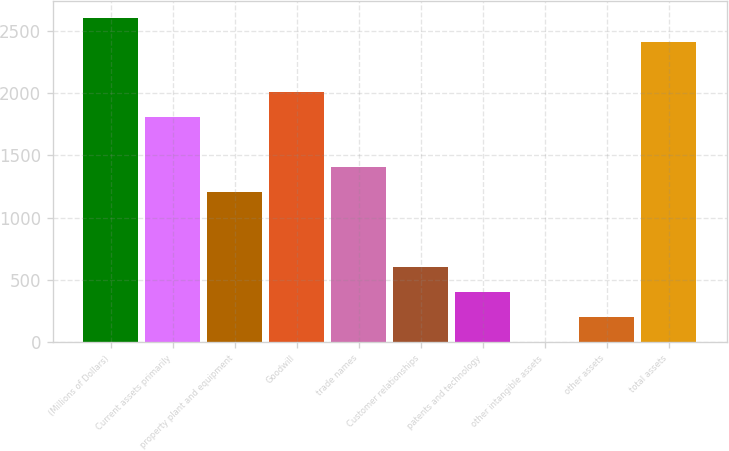Convert chart. <chart><loc_0><loc_0><loc_500><loc_500><bar_chart><fcel>(Millions of Dollars)<fcel>Current assets primarily<fcel>property plant and equipment<fcel>Goodwill<fcel>trade names<fcel>Customer relationships<fcel>patents and technology<fcel>other intangible assets<fcel>other assets<fcel>total assets<nl><fcel>2607.26<fcel>1805.58<fcel>1204.32<fcel>2006<fcel>1404.74<fcel>603.06<fcel>402.64<fcel>1.8<fcel>202.22<fcel>2406.84<nl></chart> 